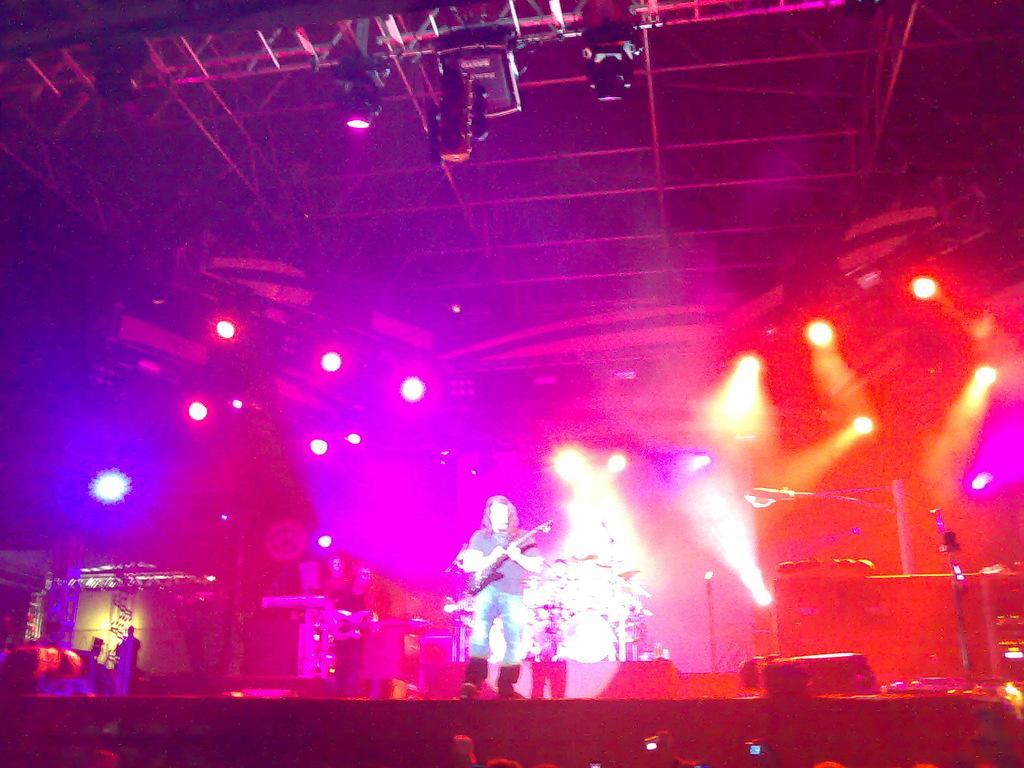In one or two sentences, can you explain what this image depicts? In this image I can see a person holding a musical instrument standing on the floor at the top I can see colorful lights. 